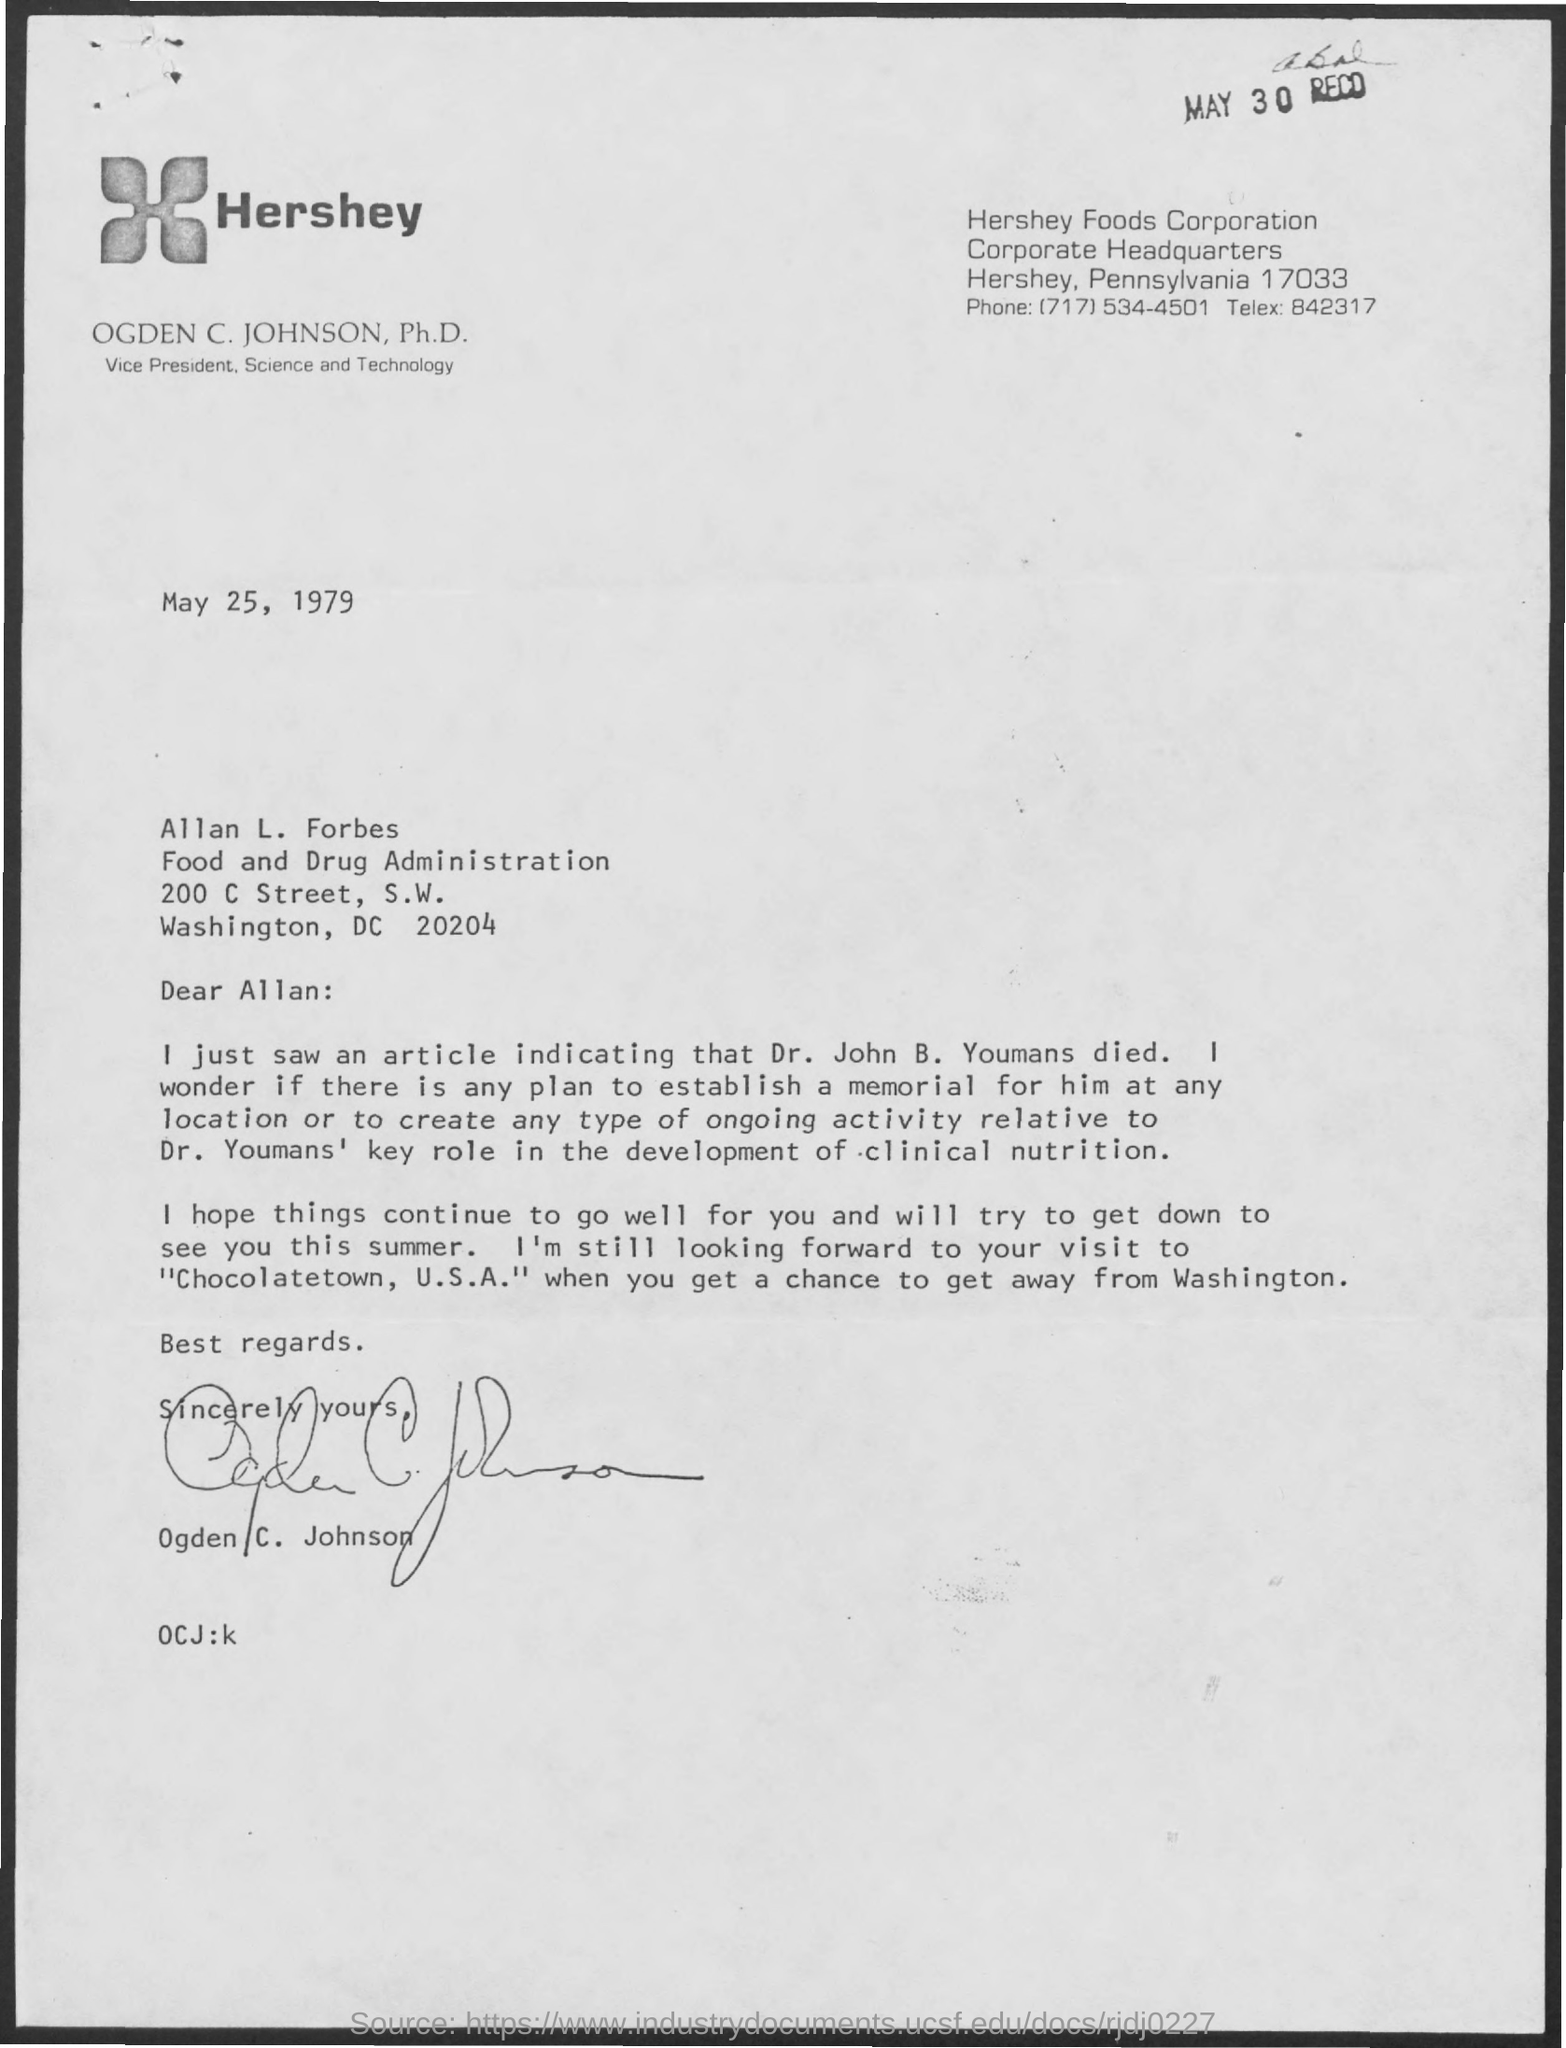List a handful of essential elements in this visual. The telex number is 842317... The phone number is (717) 534-4501. The memorandum was dated on May 25, 1979. 